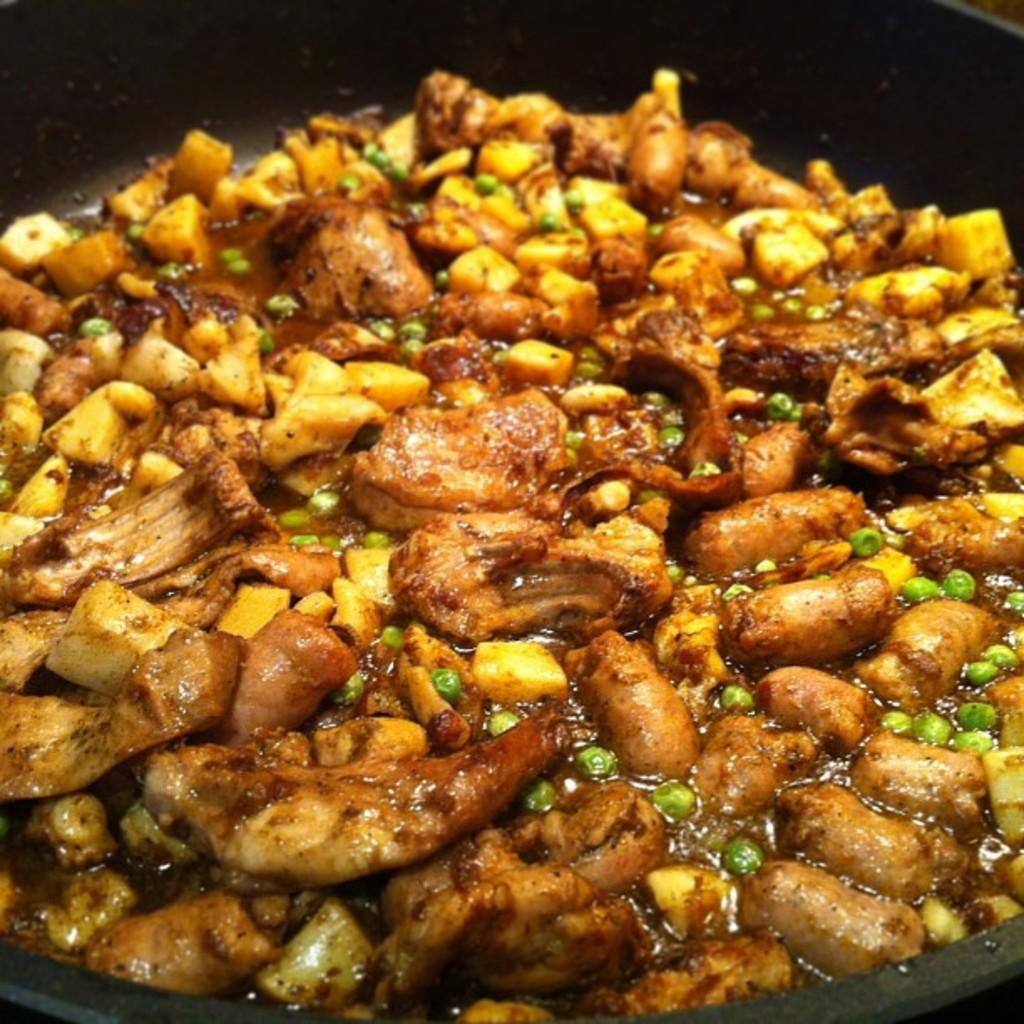What is in the bowl that is visible in the image? There are food items in a bowl in the image. What type of cart is being used by the writer in the image? There is no writer or cart present in the image; it only features a bowl of food items. 